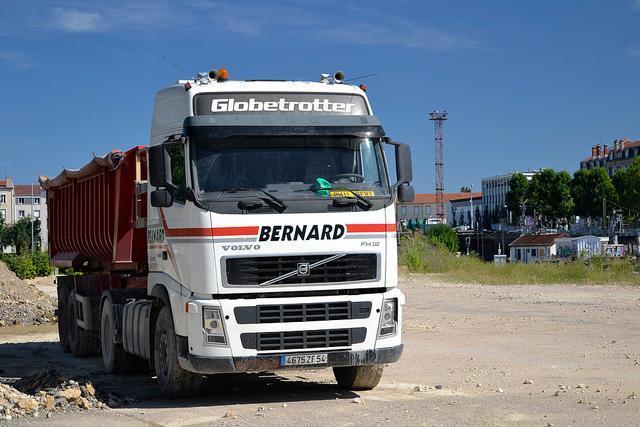How many trucks are there?
Give a very brief answer. 1. How many bottles of soap are by the sinks?
Give a very brief answer. 0. 